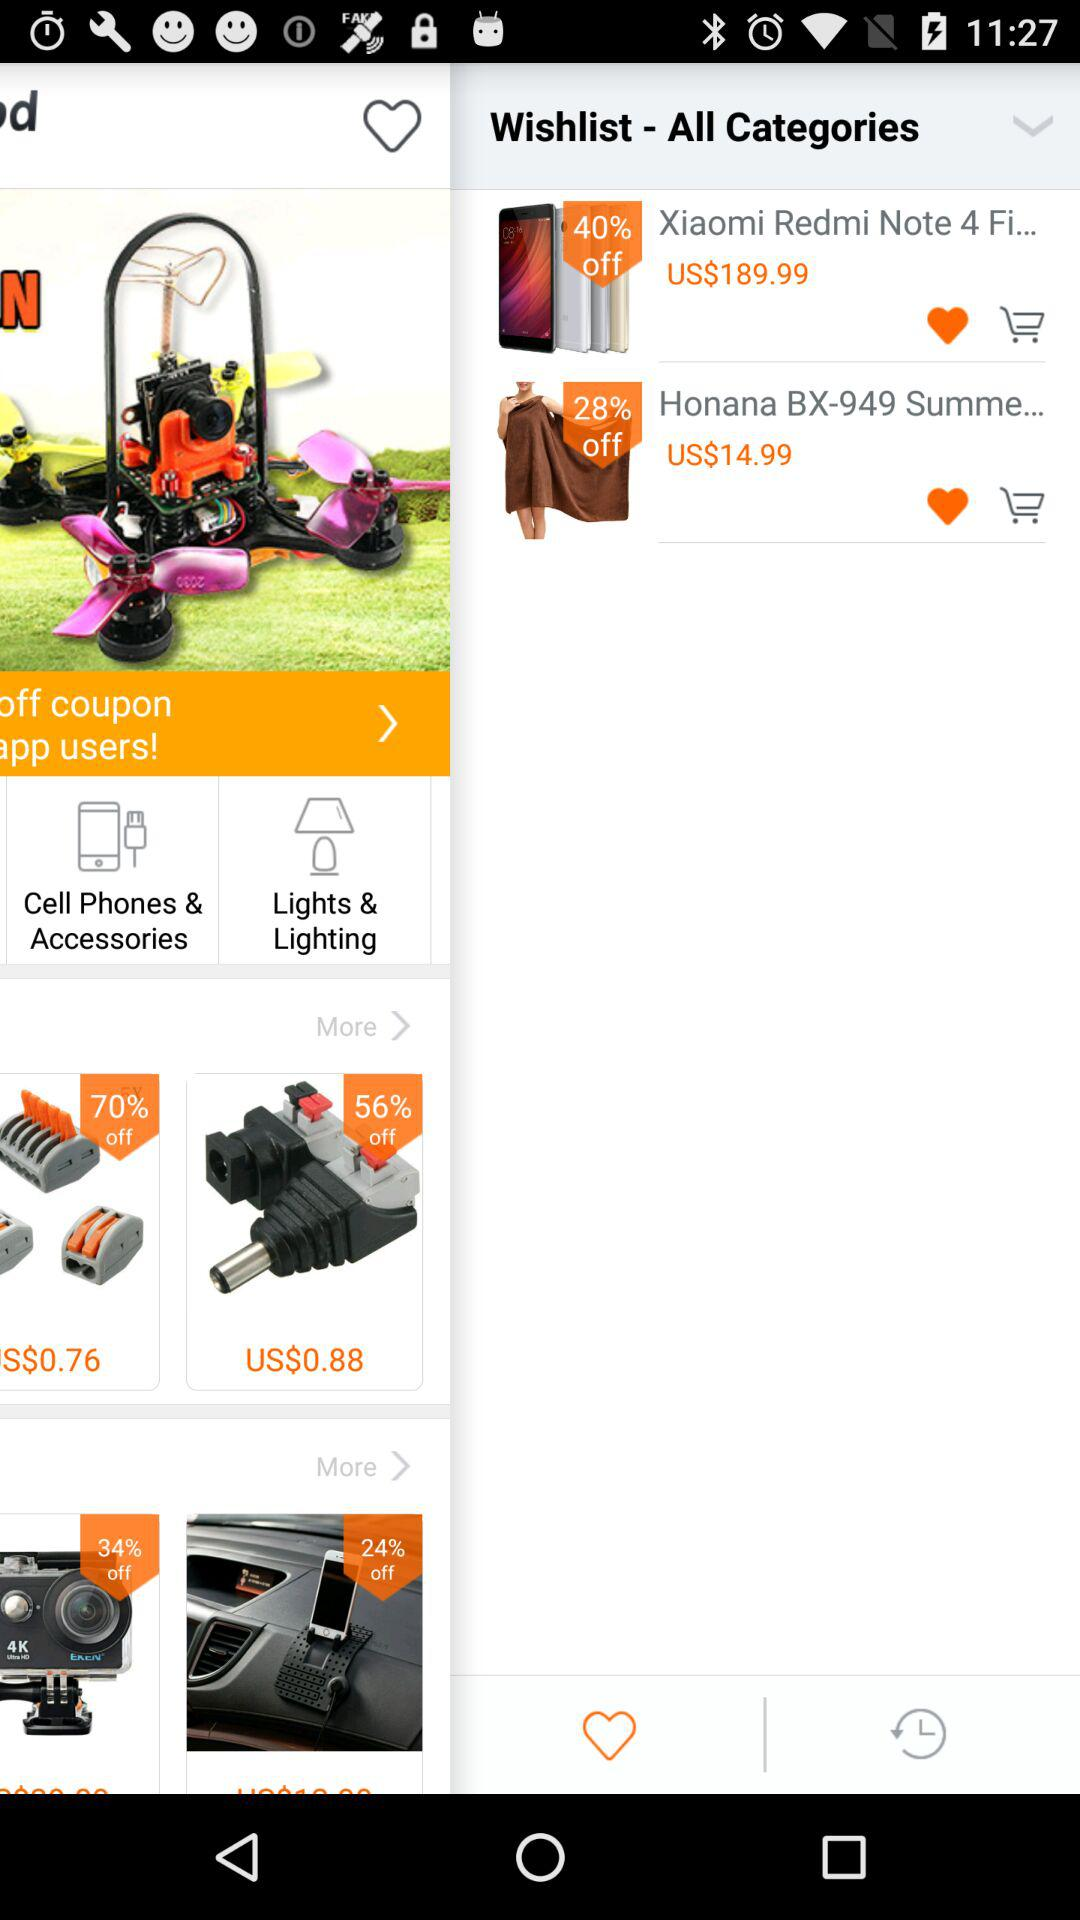What is the price of the "Xiaomi Redmi Note 4"? The price of the "Xiaomi Redmi Note 4" is US$189.99. 